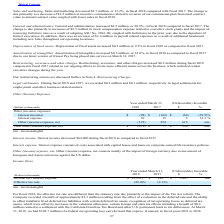According to Agilysys's financial document, What was the company recorded benefit resulting from the effect of reduction in rate? According to the financial document, $3.3 million. The relevant text states: "m. The Company recorded a benefit of approximately $3.3 million resulting from the effect of a reduction in the deferred rate and the ability to offset indefinite l..." Also, What was the benefit related to a settlement with California Franchise Tax board? According to the financial document, $0.4 million. The relevant text states: "reign and state tax effects including a benefit of $0.4 million related to a settlement with the California Franchise Tax Board and other U.S. permanent book to tax..." Also, What was the federal net operating loss carryforward at 31 March 2018? According to the financial document, $198.7 million. The relevant text states: "book to tax differences. At March 31, 2018, we had $198.7 million of a federal net operating loss carryforward that expires, if unused, in fiscal years 2031 to 2038...." Also, can you calculate: What was the average income tax (benefit) expense for 2017 and 2018? To answer this question, I need to perform calculations using the financial data. The calculation is: (-3,251 + 236) / 2, which equals -1507.5 (in thousands). This is based on the information: "Income tax (benefit) expense $ (3,251) $ 236 $ 3,487 nm Income tax (benefit) expense $ (3,251) $ 236 $ 3,487 nm..." The key data points involved are: 236, 3,251. Also, can you calculate: What was the average effective tax rate for 2017 and 2018? To answer this question, I need to perform calculations using the financial data. The calculation is: -(28.0 + 2.1) / 2, which equals -15.05 (percentage). This is based on the information: "Effective tax rate (28.0)% (2.1)% Effective tax rate (28.0)% (2.1)%..." The key data points involved are: 2.1, 28.0. Also, can you calculate: What was the increase / (decrease) in the effective tax rate from 2017 to 2018? Based on the calculation: -28.0 - (-2.1), the result is -25.9 (percentage). This is based on the information: "Effective tax rate (28.0)% (2.1)% Effective tax rate (28.0)% (2.1)%..." The key data points involved are: 2.1, 28.0. 